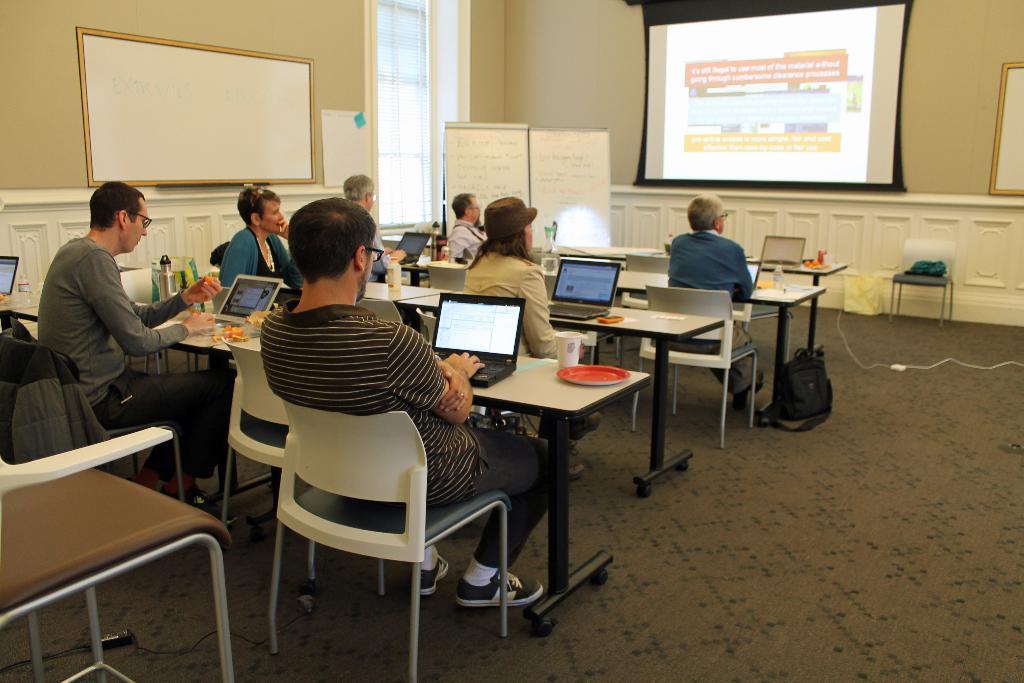Could you give a brief overview of what you see in this image? This is a whiteboard. This is a window. These are also whiteboards. This is a wall. Here we can see screen. This is a floor. here we can see a chair. We can see few persons sitting on chairs in front of a table and on the table we can see laptops, glass, water bottles and plate. 